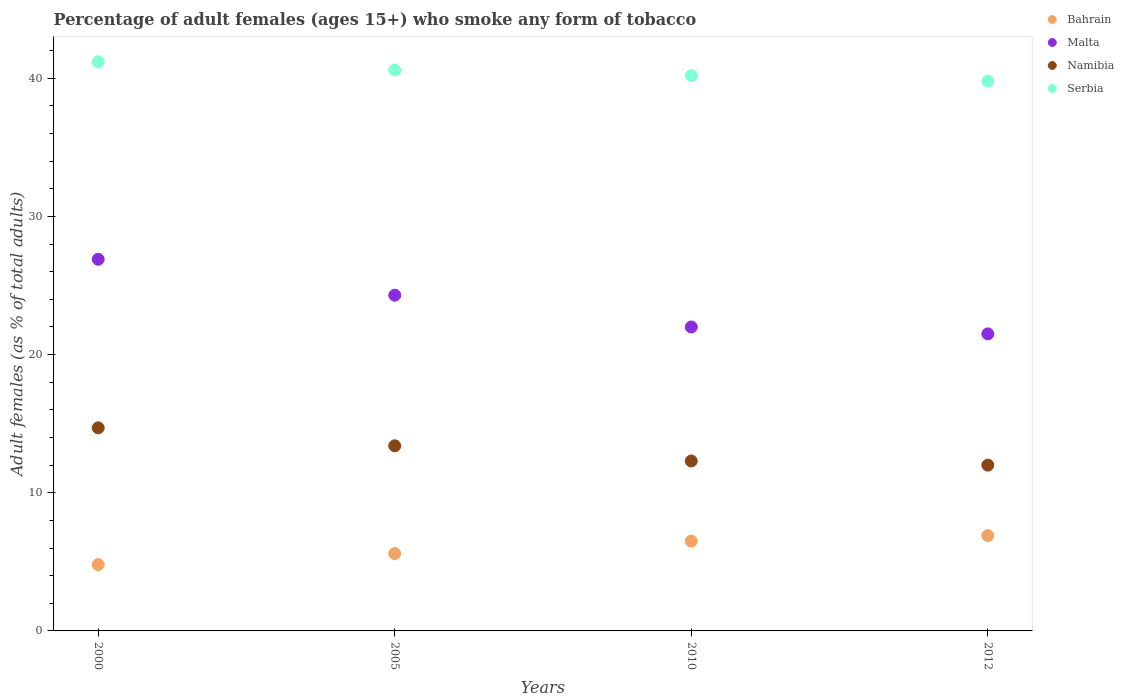How many different coloured dotlines are there?
Make the answer very short. 4. Is the number of dotlines equal to the number of legend labels?
Your answer should be compact. Yes. What is the percentage of adult females who smoke in Namibia in 2005?
Your answer should be very brief. 13.4. Across all years, what is the maximum percentage of adult females who smoke in Serbia?
Ensure brevity in your answer.  41.2. In which year was the percentage of adult females who smoke in Namibia minimum?
Keep it short and to the point. 2012. What is the total percentage of adult females who smoke in Malta in the graph?
Give a very brief answer. 94.7. What is the difference between the percentage of adult females who smoke in Malta in 2005 and that in 2010?
Offer a very short reply. 2.3. What is the difference between the percentage of adult females who smoke in Malta in 2000 and the percentage of adult females who smoke in Bahrain in 2005?
Provide a short and direct response. 21.3. What is the average percentage of adult females who smoke in Serbia per year?
Provide a succinct answer. 40.45. In the year 2005, what is the difference between the percentage of adult females who smoke in Namibia and percentage of adult females who smoke in Bahrain?
Keep it short and to the point. 7.8. In how many years, is the percentage of adult females who smoke in Malta greater than 18 %?
Offer a very short reply. 4. What is the ratio of the percentage of adult females who smoke in Serbia in 2000 to that in 2005?
Give a very brief answer. 1.01. Is the percentage of adult females who smoke in Malta in 2000 less than that in 2005?
Give a very brief answer. No. Is the difference between the percentage of adult females who smoke in Namibia in 2005 and 2012 greater than the difference between the percentage of adult females who smoke in Bahrain in 2005 and 2012?
Your answer should be very brief. Yes. What is the difference between the highest and the second highest percentage of adult females who smoke in Bahrain?
Your answer should be very brief. 0.4. What is the difference between the highest and the lowest percentage of adult females who smoke in Malta?
Provide a succinct answer. 5.4. Is it the case that in every year, the sum of the percentage of adult females who smoke in Malta and percentage of adult females who smoke in Bahrain  is greater than the sum of percentage of adult females who smoke in Serbia and percentage of adult females who smoke in Namibia?
Make the answer very short. Yes. Is it the case that in every year, the sum of the percentage of adult females who smoke in Bahrain and percentage of adult females who smoke in Malta  is greater than the percentage of adult females who smoke in Namibia?
Provide a short and direct response. Yes. Does the percentage of adult females who smoke in Malta monotonically increase over the years?
Offer a very short reply. No. How many dotlines are there?
Your answer should be compact. 4. What is the difference between two consecutive major ticks on the Y-axis?
Make the answer very short. 10. Does the graph contain any zero values?
Make the answer very short. No. Does the graph contain grids?
Ensure brevity in your answer.  No. How many legend labels are there?
Provide a succinct answer. 4. What is the title of the graph?
Make the answer very short. Percentage of adult females (ages 15+) who smoke any form of tobacco. Does "Puerto Rico" appear as one of the legend labels in the graph?
Your response must be concise. No. What is the label or title of the Y-axis?
Make the answer very short. Adult females (as % of total adults). What is the Adult females (as % of total adults) of Bahrain in 2000?
Ensure brevity in your answer.  4.8. What is the Adult females (as % of total adults) of Malta in 2000?
Give a very brief answer. 26.9. What is the Adult females (as % of total adults) in Namibia in 2000?
Make the answer very short. 14.7. What is the Adult females (as % of total adults) of Serbia in 2000?
Make the answer very short. 41.2. What is the Adult females (as % of total adults) of Malta in 2005?
Offer a very short reply. 24.3. What is the Adult females (as % of total adults) of Serbia in 2005?
Keep it short and to the point. 40.6. What is the Adult females (as % of total adults) in Bahrain in 2010?
Offer a terse response. 6.5. What is the Adult females (as % of total adults) of Serbia in 2010?
Provide a short and direct response. 40.2. What is the Adult females (as % of total adults) in Bahrain in 2012?
Ensure brevity in your answer.  6.9. What is the Adult females (as % of total adults) of Malta in 2012?
Give a very brief answer. 21.5. What is the Adult females (as % of total adults) in Namibia in 2012?
Give a very brief answer. 12. What is the Adult females (as % of total adults) of Serbia in 2012?
Provide a short and direct response. 39.8. Across all years, what is the maximum Adult females (as % of total adults) in Malta?
Provide a succinct answer. 26.9. Across all years, what is the maximum Adult females (as % of total adults) of Serbia?
Your answer should be compact. 41.2. Across all years, what is the minimum Adult females (as % of total adults) in Bahrain?
Your answer should be very brief. 4.8. Across all years, what is the minimum Adult females (as % of total adults) in Malta?
Make the answer very short. 21.5. Across all years, what is the minimum Adult females (as % of total adults) in Serbia?
Offer a terse response. 39.8. What is the total Adult females (as % of total adults) in Bahrain in the graph?
Keep it short and to the point. 23.8. What is the total Adult females (as % of total adults) of Malta in the graph?
Provide a succinct answer. 94.7. What is the total Adult females (as % of total adults) of Namibia in the graph?
Offer a terse response. 52.4. What is the total Adult females (as % of total adults) in Serbia in the graph?
Keep it short and to the point. 161.8. What is the difference between the Adult females (as % of total adults) of Namibia in 2000 and that in 2005?
Give a very brief answer. 1.3. What is the difference between the Adult females (as % of total adults) of Serbia in 2000 and that in 2005?
Your answer should be compact. 0.6. What is the difference between the Adult females (as % of total adults) of Malta in 2000 and that in 2010?
Your answer should be very brief. 4.9. What is the difference between the Adult females (as % of total adults) of Namibia in 2000 and that in 2010?
Offer a very short reply. 2.4. What is the difference between the Adult females (as % of total adults) in Bahrain in 2000 and that in 2012?
Ensure brevity in your answer.  -2.1. What is the difference between the Adult females (as % of total adults) in Malta in 2000 and that in 2012?
Give a very brief answer. 5.4. What is the difference between the Adult females (as % of total adults) of Bahrain in 2005 and that in 2010?
Your answer should be compact. -0.9. What is the difference between the Adult females (as % of total adults) in Malta in 2005 and that in 2010?
Keep it short and to the point. 2.3. What is the difference between the Adult females (as % of total adults) in Namibia in 2005 and that in 2010?
Offer a terse response. 1.1. What is the difference between the Adult females (as % of total adults) of Bahrain in 2005 and that in 2012?
Offer a very short reply. -1.3. What is the difference between the Adult females (as % of total adults) of Serbia in 2005 and that in 2012?
Keep it short and to the point. 0.8. What is the difference between the Adult females (as % of total adults) in Malta in 2010 and that in 2012?
Your answer should be compact. 0.5. What is the difference between the Adult females (as % of total adults) in Namibia in 2010 and that in 2012?
Make the answer very short. 0.3. What is the difference between the Adult females (as % of total adults) in Serbia in 2010 and that in 2012?
Your answer should be compact. 0.4. What is the difference between the Adult females (as % of total adults) of Bahrain in 2000 and the Adult females (as % of total adults) of Malta in 2005?
Make the answer very short. -19.5. What is the difference between the Adult females (as % of total adults) of Bahrain in 2000 and the Adult females (as % of total adults) of Serbia in 2005?
Make the answer very short. -35.8. What is the difference between the Adult females (as % of total adults) of Malta in 2000 and the Adult females (as % of total adults) of Namibia in 2005?
Make the answer very short. 13.5. What is the difference between the Adult females (as % of total adults) in Malta in 2000 and the Adult females (as % of total adults) in Serbia in 2005?
Offer a terse response. -13.7. What is the difference between the Adult females (as % of total adults) of Namibia in 2000 and the Adult females (as % of total adults) of Serbia in 2005?
Offer a terse response. -25.9. What is the difference between the Adult females (as % of total adults) in Bahrain in 2000 and the Adult females (as % of total adults) in Malta in 2010?
Offer a terse response. -17.2. What is the difference between the Adult females (as % of total adults) of Bahrain in 2000 and the Adult females (as % of total adults) of Namibia in 2010?
Your answer should be compact. -7.5. What is the difference between the Adult females (as % of total adults) in Bahrain in 2000 and the Adult females (as % of total adults) in Serbia in 2010?
Your answer should be very brief. -35.4. What is the difference between the Adult females (as % of total adults) in Namibia in 2000 and the Adult females (as % of total adults) in Serbia in 2010?
Give a very brief answer. -25.5. What is the difference between the Adult females (as % of total adults) in Bahrain in 2000 and the Adult females (as % of total adults) in Malta in 2012?
Make the answer very short. -16.7. What is the difference between the Adult females (as % of total adults) in Bahrain in 2000 and the Adult females (as % of total adults) in Namibia in 2012?
Make the answer very short. -7.2. What is the difference between the Adult females (as % of total adults) in Bahrain in 2000 and the Adult females (as % of total adults) in Serbia in 2012?
Your response must be concise. -35. What is the difference between the Adult females (as % of total adults) in Malta in 2000 and the Adult females (as % of total adults) in Namibia in 2012?
Make the answer very short. 14.9. What is the difference between the Adult females (as % of total adults) in Namibia in 2000 and the Adult females (as % of total adults) in Serbia in 2012?
Keep it short and to the point. -25.1. What is the difference between the Adult females (as % of total adults) in Bahrain in 2005 and the Adult females (as % of total adults) in Malta in 2010?
Provide a short and direct response. -16.4. What is the difference between the Adult females (as % of total adults) in Bahrain in 2005 and the Adult females (as % of total adults) in Serbia in 2010?
Make the answer very short. -34.6. What is the difference between the Adult females (as % of total adults) in Malta in 2005 and the Adult females (as % of total adults) in Namibia in 2010?
Offer a very short reply. 12. What is the difference between the Adult females (as % of total adults) in Malta in 2005 and the Adult females (as % of total adults) in Serbia in 2010?
Make the answer very short. -15.9. What is the difference between the Adult females (as % of total adults) of Namibia in 2005 and the Adult females (as % of total adults) of Serbia in 2010?
Your answer should be very brief. -26.8. What is the difference between the Adult females (as % of total adults) in Bahrain in 2005 and the Adult females (as % of total adults) in Malta in 2012?
Provide a succinct answer. -15.9. What is the difference between the Adult females (as % of total adults) in Bahrain in 2005 and the Adult females (as % of total adults) in Serbia in 2012?
Your answer should be compact. -34.2. What is the difference between the Adult females (as % of total adults) in Malta in 2005 and the Adult females (as % of total adults) in Namibia in 2012?
Provide a short and direct response. 12.3. What is the difference between the Adult females (as % of total adults) in Malta in 2005 and the Adult females (as % of total adults) in Serbia in 2012?
Your answer should be very brief. -15.5. What is the difference between the Adult females (as % of total adults) of Namibia in 2005 and the Adult females (as % of total adults) of Serbia in 2012?
Make the answer very short. -26.4. What is the difference between the Adult females (as % of total adults) in Bahrain in 2010 and the Adult females (as % of total adults) in Malta in 2012?
Offer a very short reply. -15. What is the difference between the Adult females (as % of total adults) in Bahrain in 2010 and the Adult females (as % of total adults) in Namibia in 2012?
Offer a terse response. -5.5. What is the difference between the Adult females (as % of total adults) in Bahrain in 2010 and the Adult females (as % of total adults) in Serbia in 2012?
Make the answer very short. -33.3. What is the difference between the Adult females (as % of total adults) of Malta in 2010 and the Adult females (as % of total adults) of Namibia in 2012?
Provide a short and direct response. 10. What is the difference between the Adult females (as % of total adults) of Malta in 2010 and the Adult females (as % of total adults) of Serbia in 2012?
Offer a very short reply. -17.8. What is the difference between the Adult females (as % of total adults) in Namibia in 2010 and the Adult females (as % of total adults) in Serbia in 2012?
Your answer should be compact. -27.5. What is the average Adult females (as % of total adults) in Bahrain per year?
Ensure brevity in your answer.  5.95. What is the average Adult females (as % of total adults) of Malta per year?
Offer a terse response. 23.68. What is the average Adult females (as % of total adults) of Namibia per year?
Keep it short and to the point. 13.1. What is the average Adult females (as % of total adults) in Serbia per year?
Keep it short and to the point. 40.45. In the year 2000, what is the difference between the Adult females (as % of total adults) in Bahrain and Adult females (as % of total adults) in Malta?
Your answer should be compact. -22.1. In the year 2000, what is the difference between the Adult females (as % of total adults) in Bahrain and Adult females (as % of total adults) in Serbia?
Ensure brevity in your answer.  -36.4. In the year 2000, what is the difference between the Adult females (as % of total adults) of Malta and Adult females (as % of total adults) of Serbia?
Provide a succinct answer. -14.3. In the year 2000, what is the difference between the Adult females (as % of total adults) in Namibia and Adult females (as % of total adults) in Serbia?
Your answer should be compact. -26.5. In the year 2005, what is the difference between the Adult females (as % of total adults) in Bahrain and Adult females (as % of total adults) in Malta?
Your answer should be compact. -18.7. In the year 2005, what is the difference between the Adult females (as % of total adults) of Bahrain and Adult females (as % of total adults) of Serbia?
Keep it short and to the point. -35. In the year 2005, what is the difference between the Adult females (as % of total adults) of Malta and Adult females (as % of total adults) of Namibia?
Ensure brevity in your answer.  10.9. In the year 2005, what is the difference between the Adult females (as % of total adults) of Malta and Adult females (as % of total adults) of Serbia?
Give a very brief answer. -16.3. In the year 2005, what is the difference between the Adult females (as % of total adults) in Namibia and Adult females (as % of total adults) in Serbia?
Your response must be concise. -27.2. In the year 2010, what is the difference between the Adult females (as % of total adults) in Bahrain and Adult females (as % of total adults) in Malta?
Your answer should be compact. -15.5. In the year 2010, what is the difference between the Adult females (as % of total adults) in Bahrain and Adult females (as % of total adults) in Namibia?
Your answer should be very brief. -5.8. In the year 2010, what is the difference between the Adult females (as % of total adults) of Bahrain and Adult females (as % of total adults) of Serbia?
Keep it short and to the point. -33.7. In the year 2010, what is the difference between the Adult females (as % of total adults) of Malta and Adult females (as % of total adults) of Namibia?
Your answer should be compact. 9.7. In the year 2010, what is the difference between the Adult females (as % of total adults) of Malta and Adult females (as % of total adults) of Serbia?
Keep it short and to the point. -18.2. In the year 2010, what is the difference between the Adult females (as % of total adults) of Namibia and Adult females (as % of total adults) of Serbia?
Your response must be concise. -27.9. In the year 2012, what is the difference between the Adult females (as % of total adults) of Bahrain and Adult females (as % of total adults) of Malta?
Keep it short and to the point. -14.6. In the year 2012, what is the difference between the Adult females (as % of total adults) of Bahrain and Adult females (as % of total adults) of Serbia?
Keep it short and to the point. -32.9. In the year 2012, what is the difference between the Adult females (as % of total adults) of Malta and Adult females (as % of total adults) of Namibia?
Your answer should be compact. 9.5. In the year 2012, what is the difference between the Adult females (as % of total adults) of Malta and Adult females (as % of total adults) of Serbia?
Keep it short and to the point. -18.3. In the year 2012, what is the difference between the Adult females (as % of total adults) of Namibia and Adult females (as % of total adults) of Serbia?
Ensure brevity in your answer.  -27.8. What is the ratio of the Adult females (as % of total adults) in Bahrain in 2000 to that in 2005?
Your answer should be compact. 0.86. What is the ratio of the Adult females (as % of total adults) of Malta in 2000 to that in 2005?
Ensure brevity in your answer.  1.11. What is the ratio of the Adult females (as % of total adults) of Namibia in 2000 to that in 2005?
Your answer should be compact. 1.1. What is the ratio of the Adult females (as % of total adults) in Serbia in 2000 to that in 2005?
Make the answer very short. 1.01. What is the ratio of the Adult females (as % of total adults) of Bahrain in 2000 to that in 2010?
Your answer should be very brief. 0.74. What is the ratio of the Adult females (as % of total adults) of Malta in 2000 to that in 2010?
Your response must be concise. 1.22. What is the ratio of the Adult females (as % of total adults) of Namibia in 2000 to that in 2010?
Provide a succinct answer. 1.2. What is the ratio of the Adult females (as % of total adults) in Serbia in 2000 to that in 2010?
Your answer should be compact. 1.02. What is the ratio of the Adult females (as % of total adults) in Bahrain in 2000 to that in 2012?
Offer a very short reply. 0.7. What is the ratio of the Adult females (as % of total adults) in Malta in 2000 to that in 2012?
Your answer should be very brief. 1.25. What is the ratio of the Adult females (as % of total adults) in Namibia in 2000 to that in 2012?
Make the answer very short. 1.23. What is the ratio of the Adult females (as % of total adults) of Serbia in 2000 to that in 2012?
Ensure brevity in your answer.  1.04. What is the ratio of the Adult females (as % of total adults) of Bahrain in 2005 to that in 2010?
Provide a succinct answer. 0.86. What is the ratio of the Adult females (as % of total adults) of Malta in 2005 to that in 2010?
Make the answer very short. 1.1. What is the ratio of the Adult females (as % of total adults) in Namibia in 2005 to that in 2010?
Keep it short and to the point. 1.09. What is the ratio of the Adult females (as % of total adults) in Bahrain in 2005 to that in 2012?
Give a very brief answer. 0.81. What is the ratio of the Adult females (as % of total adults) in Malta in 2005 to that in 2012?
Provide a succinct answer. 1.13. What is the ratio of the Adult females (as % of total adults) in Namibia in 2005 to that in 2012?
Make the answer very short. 1.12. What is the ratio of the Adult females (as % of total adults) in Serbia in 2005 to that in 2012?
Provide a succinct answer. 1.02. What is the ratio of the Adult females (as % of total adults) of Bahrain in 2010 to that in 2012?
Keep it short and to the point. 0.94. What is the ratio of the Adult females (as % of total adults) of Malta in 2010 to that in 2012?
Keep it short and to the point. 1.02. What is the ratio of the Adult females (as % of total adults) in Serbia in 2010 to that in 2012?
Provide a short and direct response. 1.01. What is the difference between the highest and the second highest Adult females (as % of total adults) of Serbia?
Provide a succinct answer. 0.6. What is the difference between the highest and the lowest Adult females (as % of total adults) of Bahrain?
Provide a succinct answer. 2.1. What is the difference between the highest and the lowest Adult females (as % of total adults) in Malta?
Keep it short and to the point. 5.4. What is the difference between the highest and the lowest Adult females (as % of total adults) of Namibia?
Provide a short and direct response. 2.7. What is the difference between the highest and the lowest Adult females (as % of total adults) in Serbia?
Offer a terse response. 1.4. 